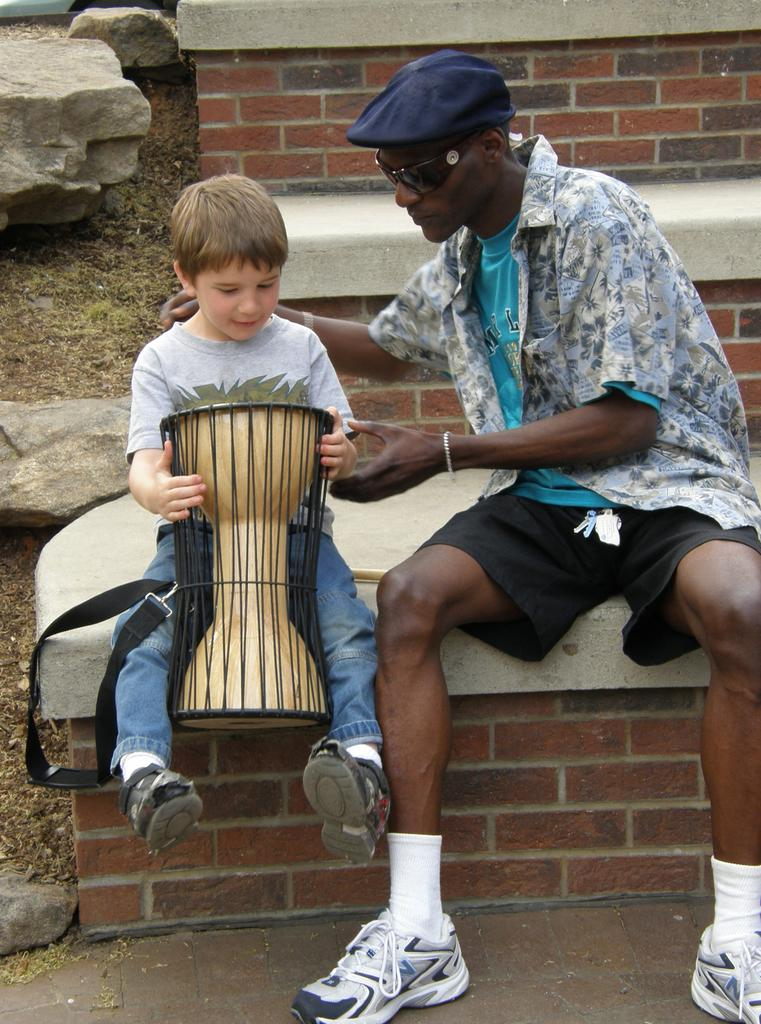How many people are in the image? There are two persons in the image. What is the person on the left wearing? The person on the left has goggles and is wearing a cap. What is the gender of the person holding the drum? The person holding the drum is a boy. What is the boy doing with his hands? The boy is holding a drum with his hands. What type of sand can be seen in the image? There is no sand present in the image. Are there any bushes visible in the image? There is no mention of bushes in the provided facts, so we cannot determine if they are present in the image. What is the boy using to transport the crate in the image? There is no crate present in the image. 